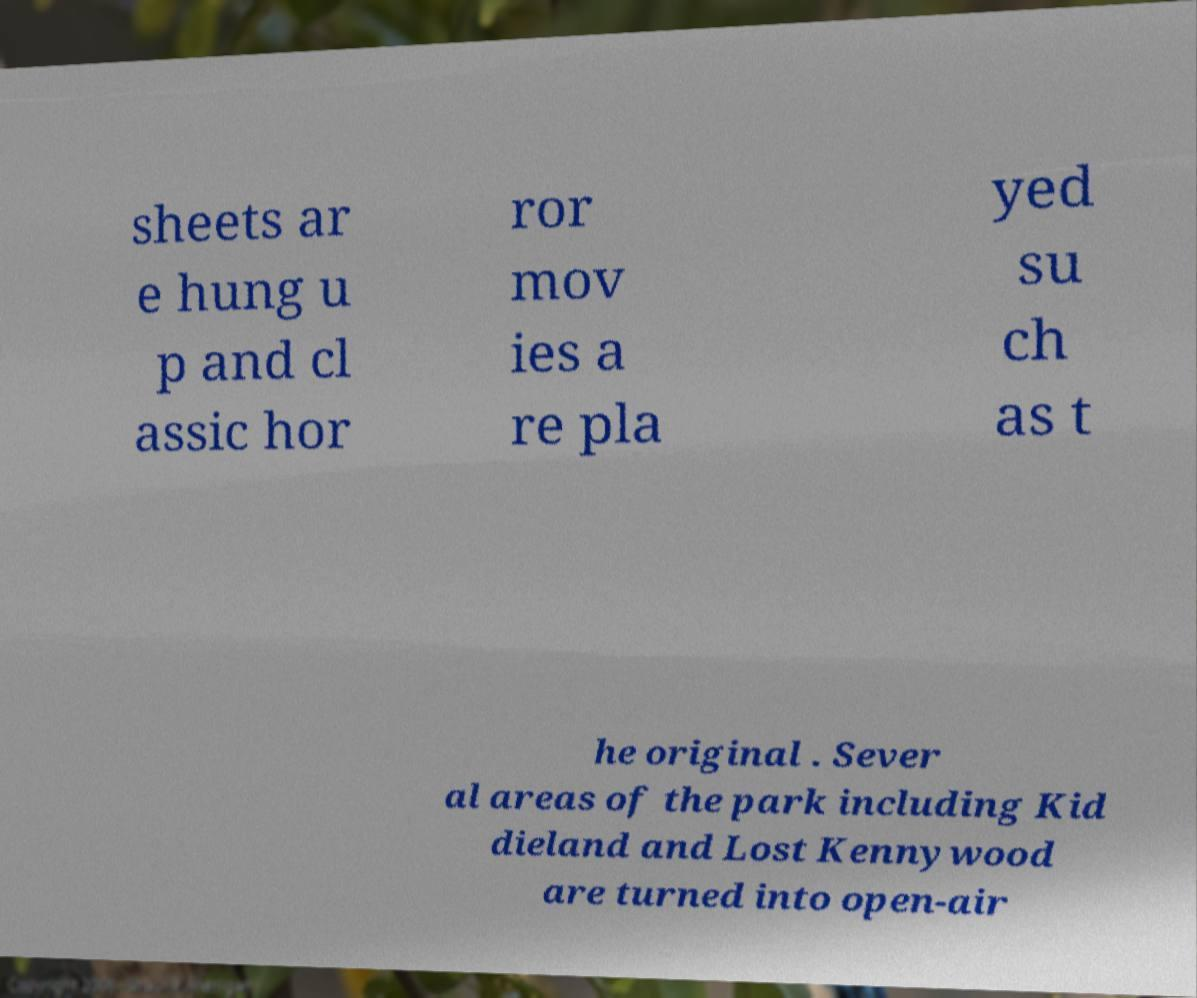There's text embedded in this image that I need extracted. Can you transcribe it verbatim? sheets ar e hung u p and cl assic hor ror mov ies a re pla yed su ch as t he original . Sever al areas of the park including Kid dieland and Lost Kennywood are turned into open-air 